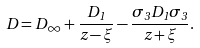Convert formula to latex. <formula><loc_0><loc_0><loc_500><loc_500>D = D _ { \infty } + \frac { D _ { 1 } } { z - \xi } - \frac { \sigma _ { 3 } D _ { 1 } \sigma _ { 3 } } { z + \xi } .</formula> 